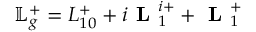<formula> <loc_0><loc_0><loc_500><loc_500>\mathbb { L } _ { g } ^ { + } = L _ { 1 0 } ^ { + } + i L _ { 1 } ^ { i + } + L _ { 1 } ^ { + }</formula> 